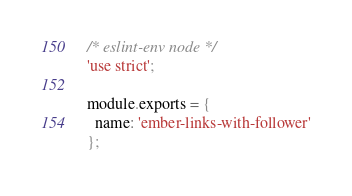<code> <loc_0><loc_0><loc_500><loc_500><_JavaScript_>/* eslint-env node */
'use strict';

module.exports = {
  name: 'ember-links-with-follower'
};
</code> 